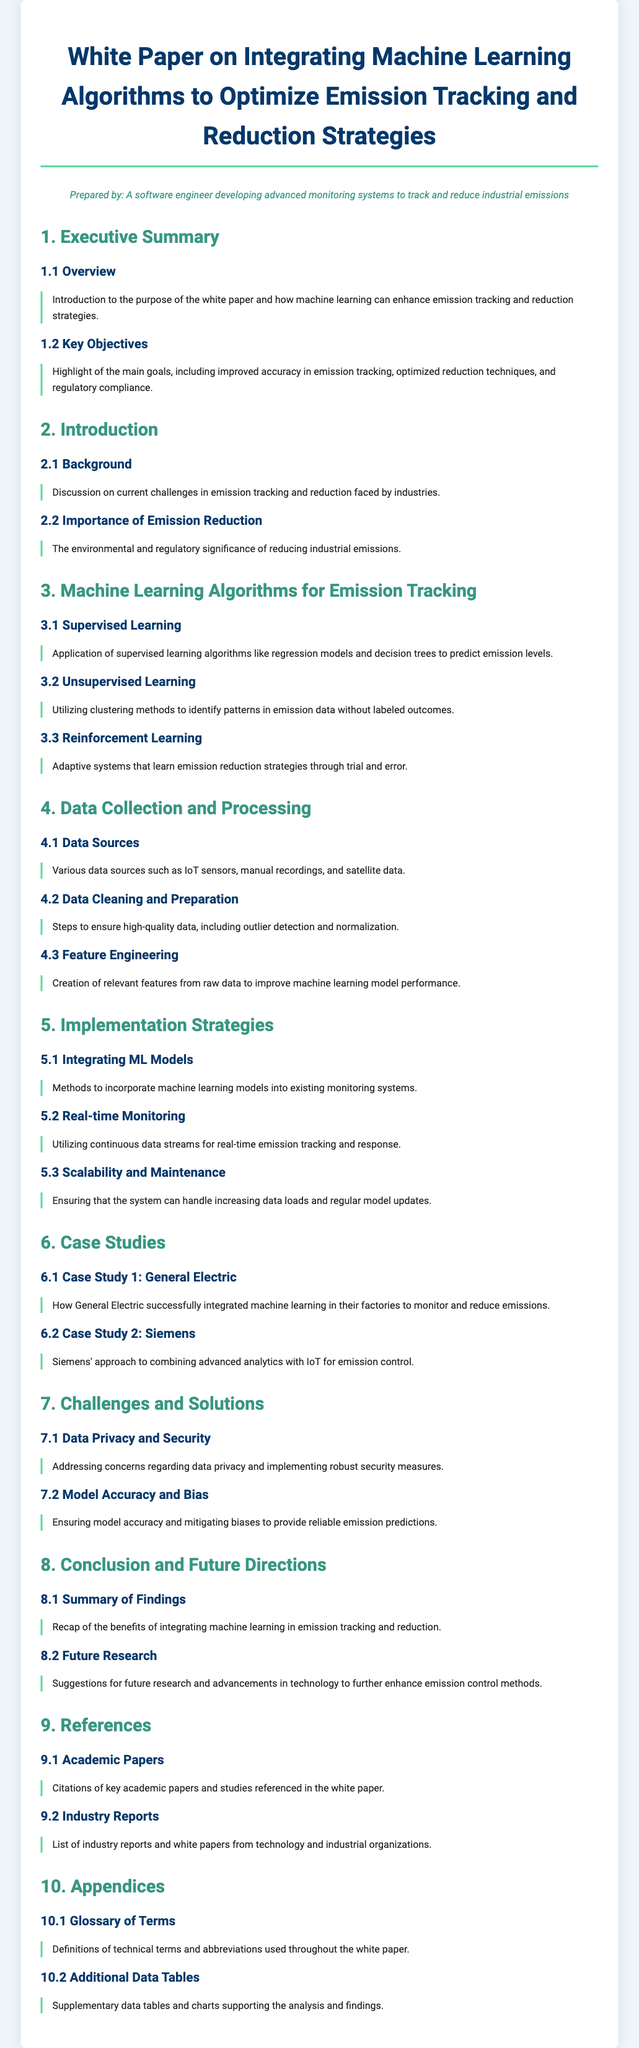What is the main purpose of the white paper? The purpose is to explain how machine learning can enhance emission tracking and reduction strategies.
Answer: Enhance emission tracking and reduction strategies What are the key objectives outlined in the document? The key objectives include improved accuracy in emission tracking, optimized reduction techniques, and regulatory compliance.
Answer: Improved accuracy, optimized reduction techniques, regulatory compliance Which machine learning algorithm is associated with predicting emission levels? The document states that supervised learning algorithms are used for predicting emission levels.
Answer: Supervised learning algorithms What are the two types of learning mentioned under machine learning algorithms? The document mentions supervised learning and unsupervised learning as types of machine learning algorithms.
Answer: Supervised learning, unsupervised learning What case study is presented for General Electric? The document discusses how General Electric successfully integrated machine learning in their factories to monitor and reduce emissions.
Answer: Successfully integrated machine learning What are the challenges concerning data mentioned in the document? The challenges include data privacy and security, as well as model accuracy and bias.
Answer: Data privacy and security, model accuracy and bias What is suggested for future research in the document? Suggestions for future research include advancements in technology to enhance emission control methods.
Answer: Advancements in technology What section discusses the integration of ML models? The section discussing the integration of ML models is titled "Integrating ML Models".
Answer: Integrating ML Models How many case studies are presented in the document? The document presents two case studies.
Answer: Two case studies 